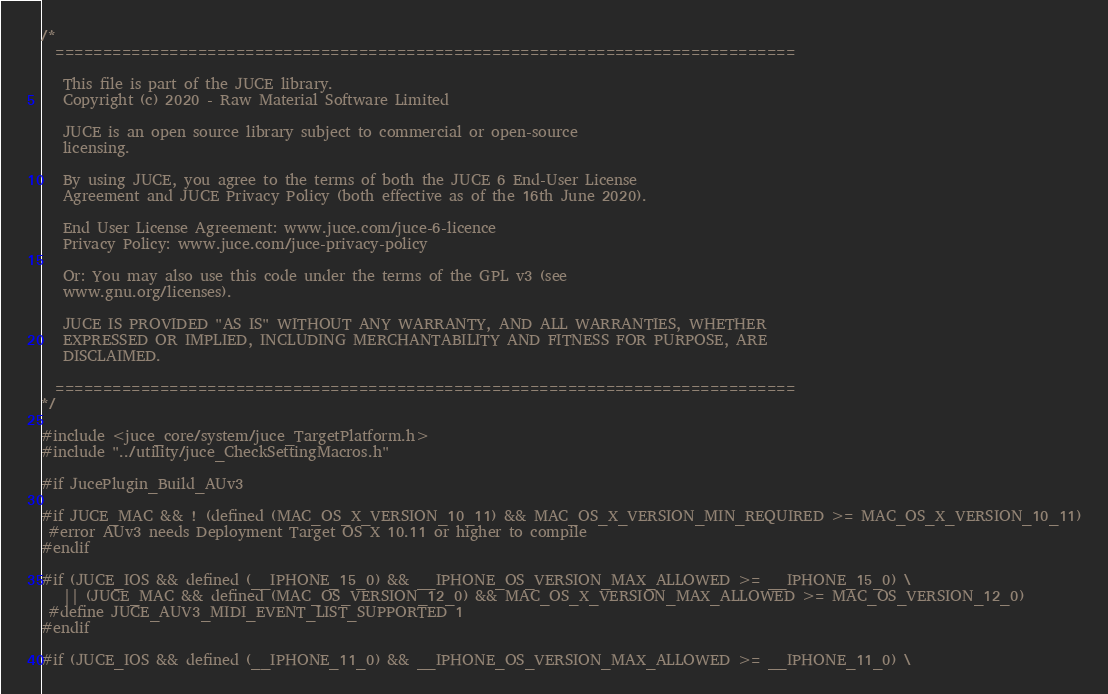<code> <loc_0><loc_0><loc_500><loc_500><_ObjectiveC_>/*
  ==============================================================================

   This file is part of the JUCE library.
   Copyright (c) 2020 - Raw Material Software Limited

   JUCE is an open source library subject to commercial or open-source
   licensing.

   By using JUCE, you agree to the terms of both the JUCE 6 End-User License
   Agreement and JUCE Privacy Policy (both effective as of the 16th June 2020).

   End User License Agreement: www.juce.com/juce-6-licence
   Privacy Policy: www.juce.com/juce-privacy-policy

   Or: You may also use this code under the terms of the GPL v3 (see
   www.gnu.org/licenses).

   JUCE IS PROVIDED "AS IS" WITHOUT ANY WARRANTY, AND ALL WARRANTIES, WHETHER
   EXPRESSED OR IMPLIED, INCLUDING MERCHANTABILITY AND FITNESS FOR PURPOSE, ARE
   DISCLAIMED.

  ==============================================================================
*/

#include <juce_core/system/juce_TargetPlatform.h>
#include "../utility/juce_CheckSettingMacros.h"

#if JucePlugin_Build_AUv3

#if JUCE_MAC && ! (defined (MAC_OS_X_VERSION_10_11) && MAC_OS_X_VERSION_MIN_REQUIRED >= MAC_OS_X_VERSION_10_11)
 #error AUv3 needs Deployment Target OS X 10.11 or higher to compile
#endif

#if (JUCE_IOS && defined (__IPHONE_15_0) && __IPHONE_OS_VERSION_MAX_ALLOWED >= __IPHONE_15_0) \
   || (JUCE_MAC && defined (MAC_OS_VERSION_12_0) && MAC_OS_X_VERSION_MAX_ALLOWED >= MAC_OS_VERSION_12_0)
 #define JUCE_AUV3_MIDI_EVENT_LIST_SUPPORTED 1
#endif

#if (JUCE_IOS && defined (__IPHONE_11_0) && __IPHONE_OS_VERSION_MAX_ALLOWED >= __IPHONE_11_0) \</code> 